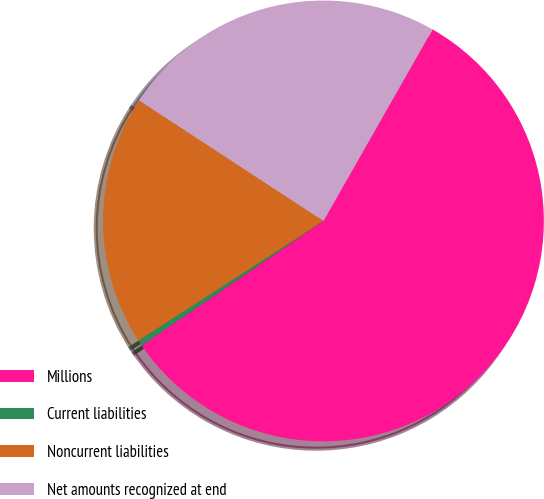<chart> <loc_0><loc_0><loc_500><loc_500><pie_chart><fcel>Millions<fcel>Current liabilities<fcel>Noncurrent liabilities<fcel>Net amounts recognized at end<nl><fcel>57.2%<fcel>0.43%<fcel>18.35%<fcel>24.02%<nl></chart> 